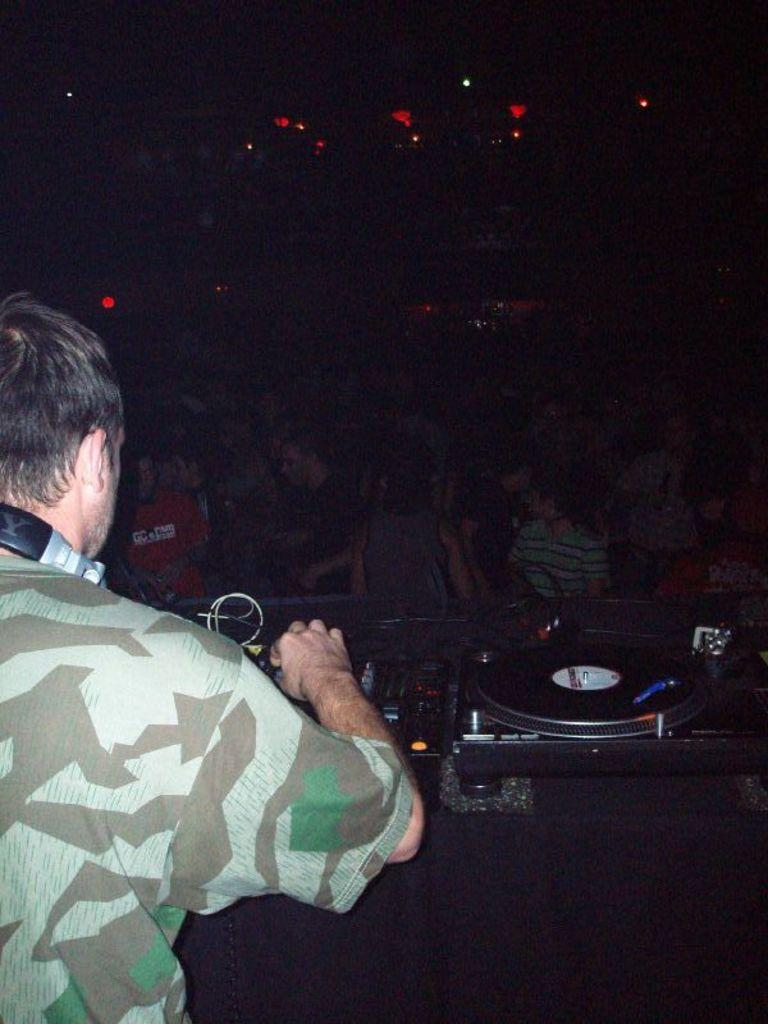What is the person in the image doing? The person in the image is playing music. What is the person using to play music? The person is using a music system. Where is the music system located in relation to the person? The music system is in front of the person. How many people are visible in the image besides the person playing music? There are a few people standing in the image. What can be said about the lighting in the image? The background of the image is dark. How many ants can be seen carrying the loss in the image? There are no ants or any reference to loss in the image; it features a person playing music with a music system. 